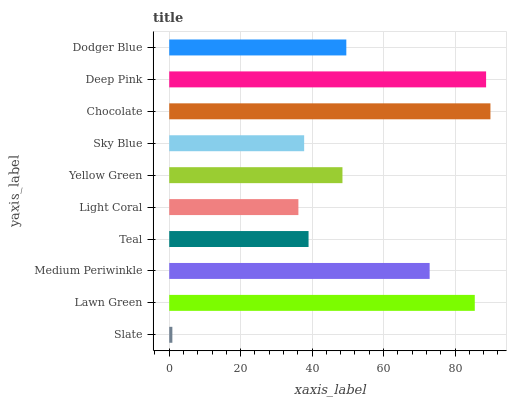Is Slate the minimum?
Answer yes or no. Yes. Is Chocolate the maximum?
Answer yes or no. Yes. Is Lawn Green the minimum?
Answer yes or no. No. Is Lawn Green the maximum?
Answer yes or no. No. Is Lawn Green greater than Slate?
Answer yes or no. Yes. Is Slate less than Lawn Green?
Answer yes or no. Yes. Is Slate greater than Lawn Green?
Answer yes or no. No. Is Lawn Green less than Slate?
Answer yes or no. No. Is Dodger Blue the high median?
Answer yes or no. Yes. Is Yellow Green the low median?
Answer yes or no. Yes. Is Medium Periwinkle the high median?
Answer yes or no. No. Is Slate the low median?
Answer yes or no. No. 